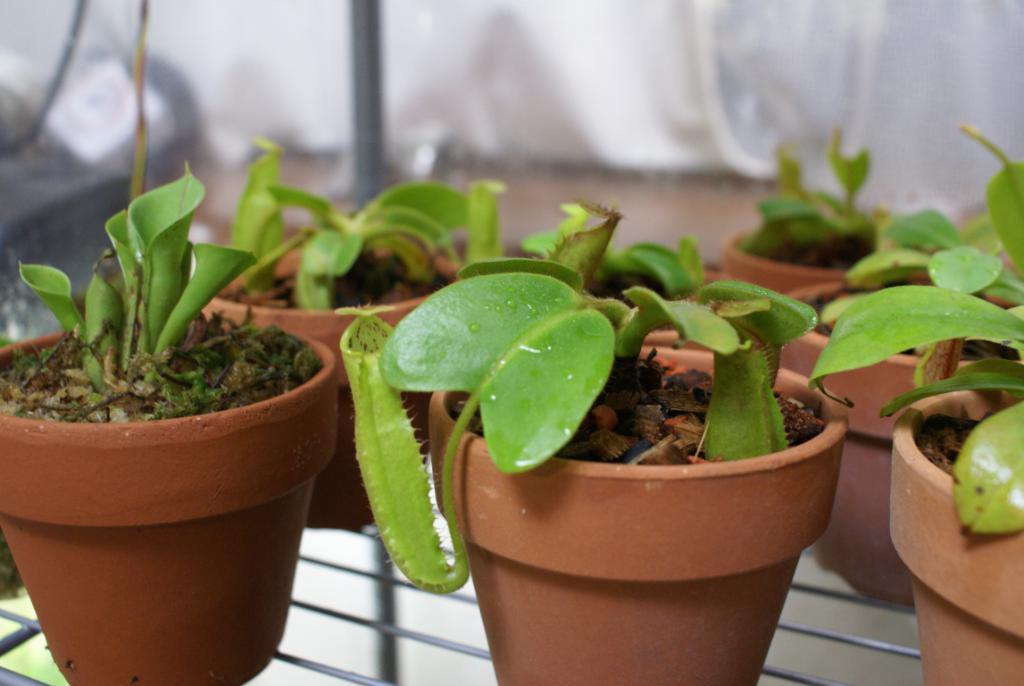How would you summarize this image in a sentence or two? In this image I see brown color pots on which there are plants which are of green in color and these pots are on the black color rods and it is blurred in the background and I see another black color rod over here. 